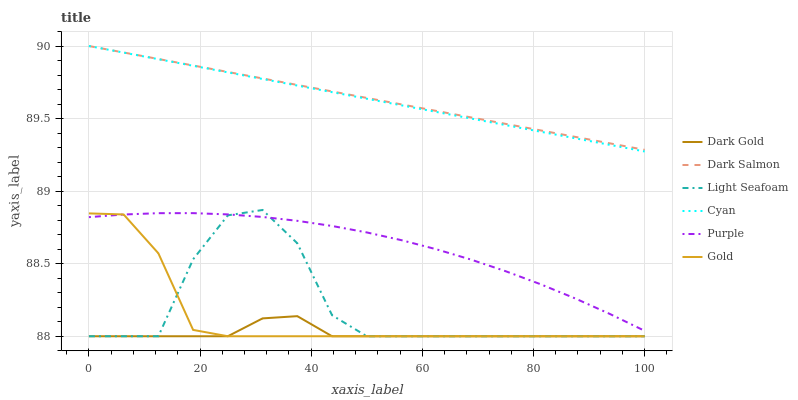Does Dark Gold have the minimum area under the curve?
Answer yes or no. Yes. Does Dark Salmon have the maximum area under the curve?
Answer yes or no. Yes. Does Purple have the minimum area under the curve?
Answer yes or no. No. Does Purple have the maximum area under the curve?
Answer yes or no. No. Is Dark Salmon the smoothest?
Answer yes or no. Yes. Is Light Seafoam the roughest?
Answer yes or no. Yes. Is Dark Gold the smoothest?
Answer yes or no. No. Is Dark Gold the roughest?
Answer yes or no. No. Does Gold have the lowest value?
Answer yes or no. Yes. Does Purple have the lowest value?
Answer yes or no. No. Does Cyan have the highest value?
Answer yes or no. Yes. Does Purple have the highest value?
Answer yes or no. No. Is Dark Gold less than Cyan?
Answer yes or no. Yes. Is Dark Salmon greater than Purple?
Answer yes or no. Yes. Does Light Seafoam intersect Purple?
Answer yes or no. Yes. Is Light Seafoam less than Purple?
Answer yes or no. No. Is Light Seafoam greater than Purple?
Answer yes or no. No. Does Dark Gold intersect Cyan?
Answer yes or no. No. 